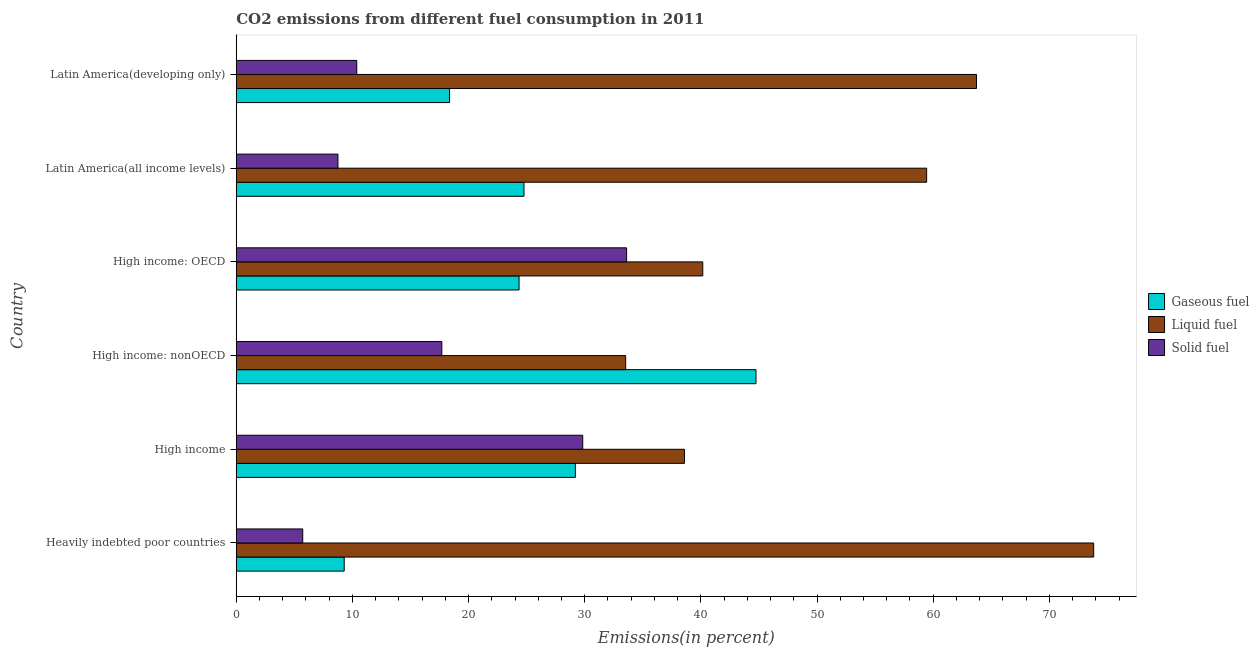How many different coloured bars are there?
Offer a terse response. 3. How many groups of bars are there?
Provide a succinct answer. 6. Are the number of bars per tick equal to the number of legend labels?
Give a very brief answer. Yes. How many bars are there on the 4th tick from the top?
Your response must be concise. 3. What is the label of the 6th group of bars from the top?
Keep it short and to the point. Heavily indebted poor countries. What is the percentage of gaseous fuel emission in Latin America(developing only)?
Your answer should be very brief. 18.36. Across all countries, what is the maximum percentage of solid fuel emission?
Provide a short and direct response. 33.61. Across all countries, what is the minimum percentage of liquid fuel emission?
Offer a very short reply. 33.53. In which country was the percentage of solid fuel emission maximum?
Your answer should be very brief. High income: OECD. In which country was the percentage of liquid fuel emission minimum?
Offer a very short reply. High income: nonOECD. What is the total percentage of liquid fuel emission in the graph?
Your answer should be very brief. 309.27. What is the difference between the percentage of gaseous fuel emission in Heavily indebted poor countries and that in Latin America(developing only)?
Provide a short and direct response. -9.07. What is the difference between the percentage of solid fuel emission in Heavily indebted poor countries and the percentage of liquid fuel emission in High income: nonOECD?
Offer a very short reply. -27.8. What is the average percentage of gaseous fuel emission per country?
Give a very brief answer. 25.12. What is the difference between the percentage of liquid fuel emission and percentage of solid fuel emission in Latin America(all income levels)?
Offer a very short reply. 50.68. In how many countries, is the percentage of gaseous fuel emission greater than 44 %?
Your response must be concise. 1. What is the ratio of the percentage of gaseous fuel emission in High income: OECD to that in High income: nonOECD?
Provide a short and direct response. 0.54. What is the difference between the highest and the second highest percentage of gaseous fuel emission?
Your answer should be compact. 15.55. What is the difference between the highest and the lowest percentage of solid fuel emission?
Provide a succinct answer. 27.88. In how many countries, is the percentage of liquid fuel emission greater than the average percentage of liquid fuel emission taken over all countries?
Give a very brief answer. 3. What does the 2nd bar from the top in High income represents?
Provide a short and direct response. Liquid fuel. What does the 1st bar from the bottom in Heavily indebted poor countries represents?
Provide a short and direct response. Gaseous fuel. Are all the bars in the graph horizontal?
Offer a very short reply. Yes. Are the values on the major ticks of X-axis written in scientific E-notation?
Provide a succinct answer. No. Does the graph contain any zero values?
Your response must be concise. No. Does the graph contain grids?
Your answer should be very brief. No. What is the title of the graph?
Make the answer very short. CO2 emissions from different fuel consumption in 2011. Does "Central government" appear as one of the legend labels in the graph?
Keep it short and to the point. No. What is the label or title of the X-axis?
Offer a very short reply. Emissions(in percent). What is the Emissions(in percent) in Gaseous fuel in Heavily indebted poor countries?
Make the answer very short. 9.29. What is the Emissions(in percent) of Liquid fuel in Heavily indebted poor countries?
Give a very brief answer. 73.82. What is the Emissions(in percent) in Solid fuel in Heavily indebted poor countries?
Your answer should be very brief. 5.72. What is the Emissions(in percent) of Gaseous fuel in High income?
Provide a succinct answer. 29.19. What is the Emissions(in percent) in Liquid fuel in High income?
Make the answer very short. 38.59. What is the Emissions(in percent) in Solid fuel in High income?
Offer a very short reply. 29.83. What is the Emissions(in percent) in Gaseous fuel in High income: nonOECD?
Keep it short and to the point. 44.75. What is the Emissions(in percent) in Liquid fuel in High income: nonOECD?
Your response must be concise. 33.53. What is the Emissions(in percent) in Solid fuel in High income: nonOECD?
Provide a succinct answer. 17.7. What is the Emissions(in percent) of Gaseous fuel in High income: OECD?
Provide a succinct answer. 24.35. What is the Emissions(in percent) in Liquid fuel in High income: OECD?
Provide a succinct answer. 40.16. What is the Emissions(in percent) of Solid fuel in High income: OECD?
Offer a very short reply. 33.61. What is the Emissions(in percent) of Gaseous fuel in Latin America(all income levels)?
Provide a short and direct response. 24.77. What is the Emissions(in percent) of Liquid fuel in Latin America(all income levels)?
Ensure brevity in your answer.  59.44. What is the Emissions(in percent) in Solid fuel in Latin America(all income levels)?
Your response must be concise. 8.76. What is the Emissions(in percent) of Gaseous fuel in Latin America(developing only)?
Keep it short and to the point. 18.36. What is the Emissions(in percent) in Liquid fuel in Latin America(developing only)?
Keep it short and to the point. 63.73. What is the Emissions(in percent) in Solid fuel in Latin America(developing only)?
Provide a succinct answer. 10.37. Across all countries, what is the maximum Emissions(in percent) in Gaseous fuel?
Ensure brevity in your answer.  44.75. Across all countries, what is the maximum Emissions(in percent) in Liquid fuel?
Ensure brevity in your answer.  73.82. Across all countries, what is the maximum Emissions(in percent) of Solid fuel?
Your answer should be very brief. 33.61. Across all countries, what is the minimum Emissions(in percent) of Gaseous fuel?
Provide a succinct answer. 9.29. Across all countries, what is the minimum Emissions(in percent) in Liquid fuel?
Your answer should be very brief. 33.53. Across all countries, what is the minimum Emissions(in percent) in Solid fuel?
Ensure brevity in your answer.  5.72. What is the total Emissions(in percent) in Gaseous fuel in the graph?
Make the answer very short. 150.72. What is the total Emissions(in percent) of Liquid fuel in the graph?
Give a very brief answer. 309.27. What is the total Emissions(in percent) in Solid fuel in the graph?
Provide a succinct answer. 105.99. What is the difference between the Emissions(in percent) of Gaseous fuel in Heavily indebted poor countries and that in High income?
Make the answer very short. -19.9. What is the difference between the Emissions(in percent) in Liquid fuel in Heavily indebted poor countries and that in High income?
Your answer should be compact. 35.23. What is the difference between the Emissions(in percent) in Solid fuel in Heavily indebted poor countries and that in High income?
Your response must be concise. -24.11. What is the difference between the Emissions(in percent) in Gaseous fuel in Heavily indebted poor countries and that in High income: nonOECD?
Make the answer very short. -35.45. What is the difference between the Emissions(in percent) of Liquid fuel in Heavily indebted poor countries and that in High income: nonOECD?
Your answer should be compact. 40.29. What is the difference between the Emissions(in percent) of Solid fuel in Heavily indebted poor countries and that in High income: nonOECD?
Your answer should be compact. -11.98. What is the difference between the Emissions(in percent) of Gaseous fuel in Heavily indebted poor countries and that in High income: OECD?
Your answer should be compact. -15.05. What is the difference between the Emissions(in percent) of Liquid fuel in Heavily indebted poor countries and that in High income: OECD?
Your answer should be very brief. 33.65. What is the difference between the Emissions(in percent) of Solid fuel in Heavily indebted poor countries and that in High income: OECD?
Provide a succinct answer. -27.88. What is the difference between the Emissions(in percent) of Gaseous fuel in Heavily indebted poor countries and that in Latin America(all income levels)?
Provide a short and direct response. -15.48. What is the difference between the Emissions(in percent) of Liquid fuel in Heavily indebted poor countries and that in Latin America(all income levels)?
Provide a short and direct response. 14.38. What is the difference between the Emissions(in percent) of Solid fuel in Heavily indebted poor countries and that in Latin America(all income levels)?
Offer a very short reply. -3.03. What is the difference between the Emissions(in percent) in Gaseous fuel in Heavily indebted poor countries and that in Latin America(developing only)?
Your answer should be very brief. -9.07. What is the difference between the Emissions(in percent) in Liquid fuel in Heavily indebted poor countries and that in Latin America(developing only)?
Ensure brevity in your answer.  10.09. What is the difference between the Emissions(in percent) in Solid fuel in Heavily indebted poor countries and that in Latin America(developing only)?
Provide a succinct answer. -4.65. What is the difference between the Emissions(in percent) of Gaseous fuel in High income and that in High income: nonOECD?
Offer a terse response. -15.55. What is the difference between the Emissions(in percent) in Liquid fuel in High income and that in High income: nonOECD?
Your response must be concise. 5.06. What is the difference between the Emissions(in percent) of Solid fuel in High income and that in High income: nonOECD?
Your answer should be compact. 12.13. What is the difference between the Emissions(in percent) in Gaseous fuel in High income and that in High income: OECD?
Ensure brevity in your answer.  4.84. What is the difference between the Emissions(in percent) in Liquid fuel in High income and that in High income: OECD?
Your answer should be very brief. -1.58. What is the difference between the Emissions(in percent) of Solid fuel in High income and that in High income: OECD?
Your response must be concise. -3.78. What is the difference between the Emissions(in percent) in Gaseous fuel in High income and that in Latin America(all income levels)?
Your answer should be compact. 4.42. What is the difference between the Emissions(in percent) of Liquid fuel in High income and that in Latin America(all income levels)?
Keep it short and to the point. -20.85. What is the difference between the Emissions(in percent) in Solid fuel in High income and that in Latin America(all income levels)?
Make the answer very short. 21.07. What is the difference between the Emissions(in percent) in Gaseous fuel in High income and that in Latin America(developing only)?
Make the answer very short. 10.83. What is the difference between the Emissions(in percent) of Liquid fuel in High income and that in Latin America(developing only)?
Give a very brief answer. -25.14. What is the difference between the Emissions(in percent) of Solid fuel in High income and that in Latin America(developing only)?
Your answer should be very brief. 19.46. What is the difference between the Emissions(in percent) of Gaseous fuel in High income: nonOECD and that in High income: OECD?
Keep it short and to the point. 20.4. What is the difference between the Emissions(in percent) in Liquid fuel in High income: nonOECD and that in High income: OECD?
Provide a short and direct response. -6.64. What is the difference between the Emissions(in percent) in Solid fuel in High income: nonOECD and that in High income: OECD?
Keep it short and to the point. -15.91. What is the difference between the Emissions(in percent) of Gaseous fuel in High income: nonOECD and that in Latin America(all income levels)?
Provide a succinct answer. 19.97. What is the difference between the Emissions(in percent) in Liquid fuel in High income: nonOECD and that in Latin America(all income levels)?
Make the answer very short. -25.91. What is the difference between the Emissions(in percent) in Solid fuel in High income: nonOECD and that in Latin America(all income levels)?
Provide a short and direct response. 8.94. What is the difference between the Emissions(in percent) of Gaseous fuel in High income: nonOECD and that in Latin America(developing only)?
Provide a succinct answer. 26.38. What is the difference between the Emissions(in percent) of Liquid fuel in High income: nonOECD and that in Latin America(developing only)?
Give a very brief answer. -30.21. What is the difference between the Emissions(in percent) of Solid fuel in High income: nonOECD and that in Latin America(developing only)?
Your answer should be very brief. 7.33. What is the difference between the Emissions(in percent) of Gaseous fuel in High income: OECD and that in Latin America(all income levels)?
Your answer should be compact. -0.42. What is the difference between the Emissions(in percent) in Liquid fuel in High income: OECD and that in Latin America(all income levels)?
Provide a short and direct response. -19.27. What is the difference between the Emissions(in percent) of Solid fuel in High income: OECD and that in Latin America(all income levels)?
Offer a terse response. 24.85. What is the difference between the Emissions(in percent) of Gaseous fuel in High income: OECD and that in Latin America(developing only)?
Your answer should be very brief. 5.98. What is the difference between the Emissions(in percent) of Liquid fuel in High income: OECD and that in Latin America(developing only)?
Your response must be concise. -23.57. What is the difference between the Emissions(in percent) in Solid fuel in High income: OECD and that in Latin America(developing only)?
Your response must be concise. 23.23. What is the difference between the Emissions(in percent) in Gaseous fuel in Latin America(all income levels) and that in Latin America(developing only)?
Offer a very short reply. 6.41. What is the difference between the Emissions(in percent) in Liquid fuel in Latin America(all income levels) and that in Latin America(developing only)?
Provide a succinct answer. -4.29. What is the difference between the Emissions(in percent) of Solid fuel in Latin America(all income levels) and that in Latin America(developing only)?
Offer a very short reply. -1.62. What is the difference between the Emissions(in percent) of Gaseous fuel in Heavily indebted poor countries and the Emissions(in percent) of Liquid fuel in High income?
Provide a short and direct response. -29.29. What is the difference between the Emissions(in percent) in Gaseous fuel in Heavily indebted poor countries and the Emissions(in percent) in Solid fuel in High income?
Your answer should be compact. -20.54. What is the difference between the Emissions(in percent) in Liquid fuel in Heavily indebted poor countries and the Emissions(in percent) in Solid fuel in High income?
Keep it short and to the point. 43.99. What is the difference between the Emissions(in percent) in Gaseous fuel in Heavily indebted poor countries and the Emissions(in percent) in Liquid fuel in High income: nonOECD?
Provide a succinct answer. -24.23. What is the difference between the Emissions(in percent) of Gaseous fuel in Heavily indebted poor countries and the Emissions(in percent) of Solid fuel in High income: nonOECD?
Make the answer very short. -8.41. What is the difference between the Emissions(in percent) in Liquid fuel in Heavily indebted poor countries and the Emissions(in percent) in Solid fuel in High income: nonOECD?
Offer a terse response. 56.12. What is the difference between the Emissions(in percent) of Gaseous fuel in Heavily indebted poor countries and the Emissions(in percent) of Liquid fuel in High income: OECD?
Your response must be concise. -30.87. What is the difference between the Emissions(in percent) in Gaseous fuel in Heavily indebted poor countries and the Emissions(in percent) in Solid fuel in High income: OECD?
Your response must be concise. -24.31. What is the difference between the Emissions(in percent) of Liquid fuel in Heavily indebted poor countries and the Emissions(in percent) of Solid fuel in High income: OECD?
Your answer should be very brief. 40.21. What is the difference between the Emissions(in percent) of Gaseous fuel in Heavily indebted poor countries and the Emissions(in percent) of Liquid fuel in Latin America(all income levels)?
Your answer should be very brief. -50.14. What is the difference between the Emissions(in percent) in Gaseous fuel in Heavily indebted poor countries and the Emissions(in percent) in Solid fuel in Latin America(all income levels)?
Make the answer very short. 0.54. What is the difference between the Emissions(in percent) in Liquid fuel in Heavily indebted poor countries and the Emissions(in percent) in Solid fuel in Latin America(all income levels)?
Your answer should be compact. 65.06. What is the difference between the Emissions(in percent) of Gaseous fuel in Heavily indebted poor countries and the Emissions(in percent) of Liquid fuel in Latin America(developing only)?
Your answer should be compact. -54.44. What is the difference between the Emissions(in percent) of Gaseous fuel in Heavily indebted poor countries and the Emissions(in percent) of Solid fuel in Latin America(developing only)?
Make the answer very short. -1.08. What is the difference between the Emissions(in percent) of Liquid fuel in Heavily indebted poor countries and the Emissions(in percent) of Solid fuel in Latin America(developing only)?
Give a very brief answer. 63.44. What is the difference between the Emissions(in percent) in Gaseous fuel in High income and the Emissions(in percent) in Liquid fuel in High income: nonOECD?
Keep it short and to the point. -4.33. What is the difference between the Emissions(in percent) in Gaseous fuel in High income and the Emissions(in percent) in Solid fuel in High income: nonOECD?
Give a very brief answer. 11.49. What is the difference between the Emissions(in percent) in Liquid fuel in High income and the Emissions(in percent) in Solid fuel in High income: nonOECD?
Provide a succinct answer. 20.89. What is the difference between the Emissions(in percent) of Gaseous fuel in High income and the Emissions(in percent) of Liquid fuel in High income: OECD?
Your answer should be very brief. -10.97. What is the difference between the Emissions(in percent) of Gaseous fuel in High income and the Emissions(in percent) of Solid fuel in High income: OECD?
Provide a short and direct response. -4.41. What is the difference between the Emissions(in percent) in Liquid fuel in High income and the Emissions(in percent) in Solid fuel in High income: OECD?
Make the answer very short. 4.98. What is the difference between the Emissions(in percent) in Gaseous fuel in High income and the Emissions(in percent) in Liquid fuel in Latin America(all income levels)?
Give a very brief answer. -30.25. What is the difference between the Emissions(in percent) of Gaseous fuel in High income and the Emissions(in percent) of Solid fuel in Latin America(all income levels)?
Provide a succinct answer. 20.44. What is the difference between the Emissions(in percent) in Liquid fuel in High income and the Emissions(in percent) in Solid fuel in Latin America(all income levels)?
Give a very brief answer. 29.83. What is the difference between the Emissions(in percent) of Gaseous fuel in High income and the Emissions(in percent) of Liquid fuel in Latin America(developing only)?
Make the answer very short. -34.54. What is the difference between the Emissions(in percent) of Gaseous fuel in High income and the Emissions(in percent) of Solid fuel in Latin America(developing only)?
Ensure brevity in your answer.  18.82. What is the difference between the Emissions(in percent) of Liquid fuel in High income and the Emissions(in percent) of Solid fuel in Latin America(developing only)?
Ensure brevity in your answer.  28.21. What is the difference between the Emissions(in percent) of Gaseous fuel in High income: nonOECD and the Emissions(in percent) of Liquid fuel in High income: OECD?
Make the answer very short. 4.58. What is the difference between the Emissions(in percent) in Gaseous fuel in High income: nonOECD and the Emissions(in percent) in Solid fuel in High income: OECD?
Your answer should be very brief. 11.14. What is the difference between the Emissions(in percent) in Liquid fuel in High income: nonOECD and the Emissions(in percent) in Solid fuel in High income: OECD?
Your answer should be very brief. -0.08. What is the difference between the Emissions(in percent) of Gaseous fuel in High income: nonOECD and the Emissions(in percent) of Liquid fuel in Latin America(all income levels)?
Offer a terse response. -14.69. What is the difference between the Emissions(in percent) of Gaseous fuel in High income: nonOECD and the Emissions(in percent) of Solid fuel in Latin America(all income levels)?
Keep it short and to the point. 35.99. What is the difference between the Emissions(in percent) in Liquid fuel in High income: nonOECD and the Emissions(in percent) in Solid fuel in Latin America(all income levels)?
Make the answer very short. 24.77. What is the difference between the Emissions(in percent) of Gaseous fuel in High income: nonOECD and the Emissions(in percent) of Liquid fuel in Latin America(developing only)?
Your answer should be compact. -18.99. What is the difference between the Emissions(in percent) in Gaseous fuel in High income: nonOECD and the Emissions(in percent) in Solid fuel in Latin America(developing only)?
Your response must be concise. 34.37. What is the difference between the Emissions(in percent) in Liquid fuel in High income: nonOECD and the Emissions(in percent) in Solid fuel in Latin America(developing only)?
Keep it short and to the point. 23.15. What is the difference between the Emissions(in percent) in Gaseous fuel in High income: OECD and the Emissions(in percent) in Liquid fuel in Latin America(all income levels)?
Keep it short and to the point. -35.09. What is the difference between the Emissions(in percent) in Gaseous fuel in High income: OECD and the Emissions(in percent) in Solid fuel in Latin America(all income levels)?
Make the answer very short. 15.59. What is the difference between the Emissions(in percent) in Liquid fuel in High income: OECD and the Emissions(in percent) in Solid fuel in Latin America(all income levels)?
Your answer should be very brief. 31.41. What is the difference between the Emissions(in percent) in Gaseous fuel in High income: OECD and the Emissions(in percent) in Liquid fuel in Latin America(developing only)?
Make the answer very short. -39.38. What is the difference between the Emissions(in percent) of Gaseous fuel in High income: OECD and the Emissions(in percent) of Solid fuel in Latin America(developing only)?
Your answer should be very brief. 13.97. What is the difference between the Emissions(in percent) of Liquid fuel in High income: OECD and the Emissions(in percent) of Solid fuel in Latin America(developing only)?
Give a very brief answer. 29.79. What is the difference between the Emissions(in percent) in Gaseous fuel in Latin America(all income levels) and the Emissions(in percent) in Liquid fuel in Latin America(developing only)?
Your answer should be compact. -38.96. What is the difference between the Emissions(in percent) of Gaseous fuel in Latin America(all income levels) and the Emissions(in percent) of Solid fuel in Latin America(developing only)?
Provide a succinct answer. 14.4. What is the difference between the Emissions(in percent) of Liquid fuel in Latin America(all income levels) and the Emissions(in percent) of Solid fuel in Latin America(developing only)?
Your answer should be compact. 49.06. What is the average Emissions(in percent) in Gaseous fuel per country?
Offer a terse response. 25.12. What is the average Emissions(in percent) in Liquid fuel per country?
Offer a terse response. 51.54. What is the average Emissions(in percent) in Solid fuel per country?
Offer a terse response. 17.66. What is the difference between the Emissions(in percent) of Gaseous fuel and Emissions(in percent) of Liquid fuel in Heavily indebted poor countries?
Offer a terse response. -64.52. What is the difference between the Emissions(in percent) of Gaseous fuel and Emissions(in percent) of Solid fuel in Heavily indebted poor countries?
Offer a very short reply. 3.57. What is the difference between the Emissions(in percent) in Liquid fuel and Emissions(in percent) in Solid fuel in Heavily indebted poor countries?
Ensure brevity in your answer.  68.09. What is the difference between the Emissions(in percent) of Gaseous fuel and Emissions(in percent) of Liquid fuel in High income?
Give a very brief answer. -9.39. What is the difference between the Emissions(in percent) of Gaseous fuel and Emissions(in percent) of Solid fuel in High income?
Your answer should be compact. -0.64. What is the difference between the Emissions(in percent) of Liquid fuel and Emissions(in percent) of Solid fuel in High income?
Your answer should be very brief. 8.76. What is the difference between the Emissions(in percent) in Gaseous fuel and Emissions(in percent) in Liquid fuel in High income: nonOECD?
Your answer should be compact. 11.22. What is the difference between the Emissions(in percent) of Gaseous fuel and Emissions(in percent) of Solid fuel in High income: nonOECD?
Make the answer very short. 27.05. What is the difference between the Emissions(in percent) in Liquid fuel and Emissions(in percent) in Solid fuel in High income: nonOECD?
Offer a terse response. 15.83. What is the difference between the Emissions(in percent) of Gaseous fuel and Emissions(in percent) of Liquid fuel in High income: OECD?
Your answer should be very brief. -15.82. What is the difference between the Emissions(in percent) of Gaseous fuel and Emissions(in percent) of Solid fuel in High income: OECD?
Provide a short and direct response. -9.26. What is the difference between the Emissions(in percent) of Liquid fuel and Emissions(in percent) of Solid fuel in High income: OECD?
Provide a succinct answer. 6.56. What is the difference between the Emissions(in percent) of Gaseous fuel and Emissions(in percent) of Liquid fuel in Latin America(all income levels)?
Make the answer very short. -34.67. What is the difference between the Emissions(in percent) of Gaseous fuel and Emissions(in percent) of Solid fuel in Latin America(all income levels)?
Offer a very short reply. 16.01. What is the difference between the Emissions(in percent) of Liquid fuel and Emissions(in percent) of Solid fuel in Latin America(all income levels)?
Your answer should be compact. 50.68. What is the difference between the Emissions(in percent) in Gaseous fuel and Emissions(in percent) in Liquid fuel in Latin America(developing only)?
Your response must be concise. -45.37. What is the difference between the Emissions(in percent) in Gaseous fuel and Emissions(in percent) in Solid fuel in Latin America(developing only)?
Offer a very short reply. 7.99. What is the difference between the Emissions(in percent) in Liquid fuel and Emissions(in percent) in Solid fuel in Latin America(developing only)?
Offer a terse response. 53.36. What is the ratio of the Emissions(in percent) of Gaseous fuel in Heavily indebted poor countries to that in High income?
Provide a short and direct response. 0.32. What is the ratio of the Emissions(in percent) in Liquid fuel in Heavily indebted poor countries to that in High income?
Your answer should be compact. 1.91. What is the ratio of the Emissions(in percent) in Solid fuel in Heavily indebted poor countries to that in High income?
Make the answer very short. 0.19. What is the ratio of the Emissions(in percent) in Gaseous fuel in Heavily indebted poor countries to that in High income: nonOECD?
Your response must be concise. 0.21. What is the ratio of the Emissions(in percent) of Liquid fuel in Heavily indebted poor countries to that in High income: nonOECD?
Provide a succinct answer. 2.2. What is the ratio of the Emissions(in percent) of Solid fuel in Heavily indebted poor countries to that in High income: nonOECD?
Your answer should be very brief. 0.32. What is the ratio of the Emissions(in percent) in Gaseous fuel in Heavily indebted poor countries to that in High income: OECD?
Your answer should be compact. 0.38. What is the ratio of the Emissions(in percent) in Liquid fuel in Heavily indebted poor countries to that in High income: OECD?
Your answer should be compact. 1.84. What is the ratio of the Emissions(in percent) of Solid fuel in Heavily indebted poor countries to that in High income: OECD?
Make the answer very short. 0.17. What is the ratio of the Emissions(in percent) in Gaseous fuel in Heavily indebted poor countries to that in Latin America(all income levels)?
Provide a succinct answer. 0.38. What is the ratio of the Emissions(in percent) in Liquid fuel in Heavily indebted poor countries to that in Latin America(all income levels)?
Ensure brevity in your answer.  1.24. What is the ratio of the Emissions(in percent) of Solid fuel in Heavily indebted poor countries to that in Latin America(all income levels)?
Keep it short and to the point. 0.65. What is the ratio of the Emissions(in percent) in Gaseous fuel in Heavily indebted poor countries to that in Latin America(developing only)?
Your answer should be very brief. 0.51. What is the ratio of the Emissions(in percent) of Liquid fuel in Heavily indebted poor countries to that in Latin America(developing only)?
Your answer should be very brief. 1.16. What is the ratio of the Emissions(in percent) of Solid fuel in Heavily indebted poor countries to that in Latin America(developing only)?
Offer a terse response. 0.55. What is the ratio of the Emissions(in percent) of Gaseous fuel in High income to that in High income: nonOECD?
Provide a short and direct response. 0.65. What is the ratio of the Emissions(in percent) of Liquid fuel in High income to that in High income: nonOECD?
Give a very brief answer. 1.15. What is the ratio of the Emissions(in percent) of Solid fuel in High income to that in High income: nonOECD?
Your response must be concise. 1.69. What is the ratio of the Emissions(in percent) in Gaseous fuel in High income to that in High income: OECD?
Keep it short and to the point. 1.2. What is the ratio of the Emissions(in percent) in Liquid fuel in High income to that in High income: OECD?
Provide a short and direct response. 0.96. What is the ratio of the Emissions(in percent) in Solid fuel in High income to that in High income: OECD?
Ensure brevity in your answer.  0.89. What is the ratio of the Emissions(in percent) of Gaseous fuel in High income to that in Latin America(all income levels)?
Offer a very short reply. 1.18. What is the ratio of the Emissions(in percent) of Liquid fuel in High income to that in Latin America(all income levels)?
Provide a succinct answer. 0.65. What is the ratio of the Emissions(in percent) of Solid fuel in High income to that in Latin America(all income levels)?
Keep it short and to the point. 3.41. What is the ratio of the Emissions(in percent) in Gaseous fuel in High income to that in Latin America(developing only)?
Offer a very short reply. 1.59. What is the ratio of the Emissions(in percent) of Liquid fuel in High income to that in Latin America(developing only)?
Your answer should be very brief. 0.61. What is the ratio of the Emissions(in percent) of Solid fuel in High income to that in Latin America(developing only)?
Make the answer very short. 2.88. What is the ratio of the Emissions(in percent) in Gaseous fuel in High income: nonOECD to that in High income: OECD?
Offer a terse response. 1.84. What is the ratio of the Emissions(in percent) of Liquid fuel in High income: nonOECD to that in High income: OECD?
Offer a very short reply. 0.83. What is the ratio of the Emissions(in percent) in Solid fuel in High income: nonOECD to that in High income: OECD?
Your answer should be compact. 0.53. What is the ratio of the Emissions(in percent) of Gaseous fuel in High income: nonOECD to that in Latin America(all income levels)?
Your response must be concise. 1.81. What is the ratio of the Emissions(in percent) of Liquid fuel in High income: nonOECD to that in Latin America(all income levels)?
Ensure brevity in your answer.  0.56. What is the ratio of the Emissions(in percent) of Solid fuel in High income: nonOECD to that in Latin America(all income levels)?
Your answer should be compact. 2.02. What is the ratio of the Emissions(in percent) in Gaseous fuel in High income: nonOECD to that in Latin America(developing only)?
Offer a very short reply. 2.44. What is the ratio of the Emissions(in percent) of Liquid fuel in High income: nonOECD to that in Latin America(developing only)?
Make the answer very short. 0.53. What is the ratio of the Emissions(in percent) of Solid fuel in High income: nonOECD to that in Latin America(developing only)?
Make the answer very short. 1.71. What is the ratio of the Emissions(in percent) in Gaseous fuel in High income: OECD to that in Latin America(all income levels)?
Your response must be concise. 0.98. What is the ratio of the Emissions(in percent) of Liquid fuel in High income: OECD to that in Latin America(all income levels)?
Offer a terse response. 0.68. What is the ratio of the Emissions(in percent) in Solid fuel in High income: OECD to that in Latin America(all income levels)?
Provide a succinct answer. 3.84. What is the ratio of the Emissions(in percent) of Gaseous fuel in High income: OECD to that in Latin America(developing only)?
Your answer should be compact. 1.33. What is the ratio of the Emissions(in percent) of Liquid fuel in High income: OECD to that in Latin America(developing only)?
Offer a terse response. 0.63. What is the ratio of the Emissions(in percent) of Solid fuel in High income: OECD to that in Latin America(developing only)?
Provide a short and direct response. 3.24. What is the ratio of the Emissions(in percent) of Gaseous fuel in Latin America(all income levels) to that in Latin America(developing only)?
Your answer should be very brief. 1.35. What is the ratio of the Emissions(in percent) in Liquid fuel in Latin America(all income levels) to that in Latin America(developing only)?
Offer a very short reply. 0.93. What is the ratio of the Emissions(in percent) in Solid fuel in Latin America(all income levels) to that in Latin America(developing only)?
Offer a terse response. 0.84. What is the difference between the highest and the second highest Emissions(in percent) of Gaseous fuel?
Provide a short and direct response. 15.55. What is the difference between the highest and the second highest Emissions(in percent) in Liquid fuel?
Your response must be concise. 10.09. What is the difference between the highest and the second highest Emissions(in percent) in Solid fuel?
Provide a short and direct response. 3.78. What is the difference between the highest and the lowest Emissions(in percent) in Gaseous fuel?
Make the answer very short. 35.45. What is the difference between the highest and the lowest Emissions(in percent) in Liquid fuel?
Give a very brief answer. 40.29. What is the difference between the highest and the lowest Emissions(in percent) of Solid fuel?
Ensure brevity in your answer.  27.88. 